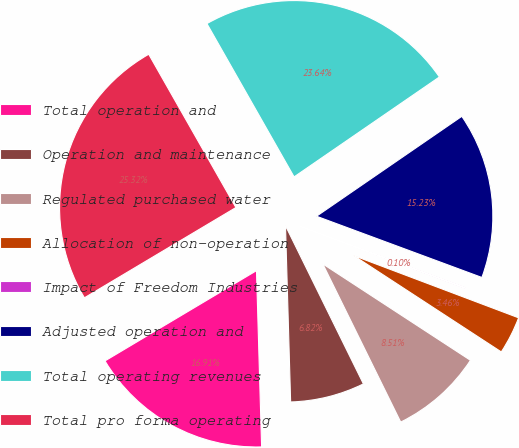Convert chart to OTSL. <chart><loc_0><loc_0><loc_500><loc_500><pie_chart><fcel>Total operation and<fcel>Operation and maintenance<fcel>Regulated purchased water<fcel>Allocation of non-operation<fcel>Impact of Freedom Industries<fcel>Adjusted operation and<fcel>Total operating revenues<fcel>Total pro forma operating<nl><fcel>16.91%<fcel>6.82%<fcel>8.51%<fcel>3.46%<fcel>0.1%<fcel>15.23%<fcel>23.64%<fcel>25.32%<nl></chart> 